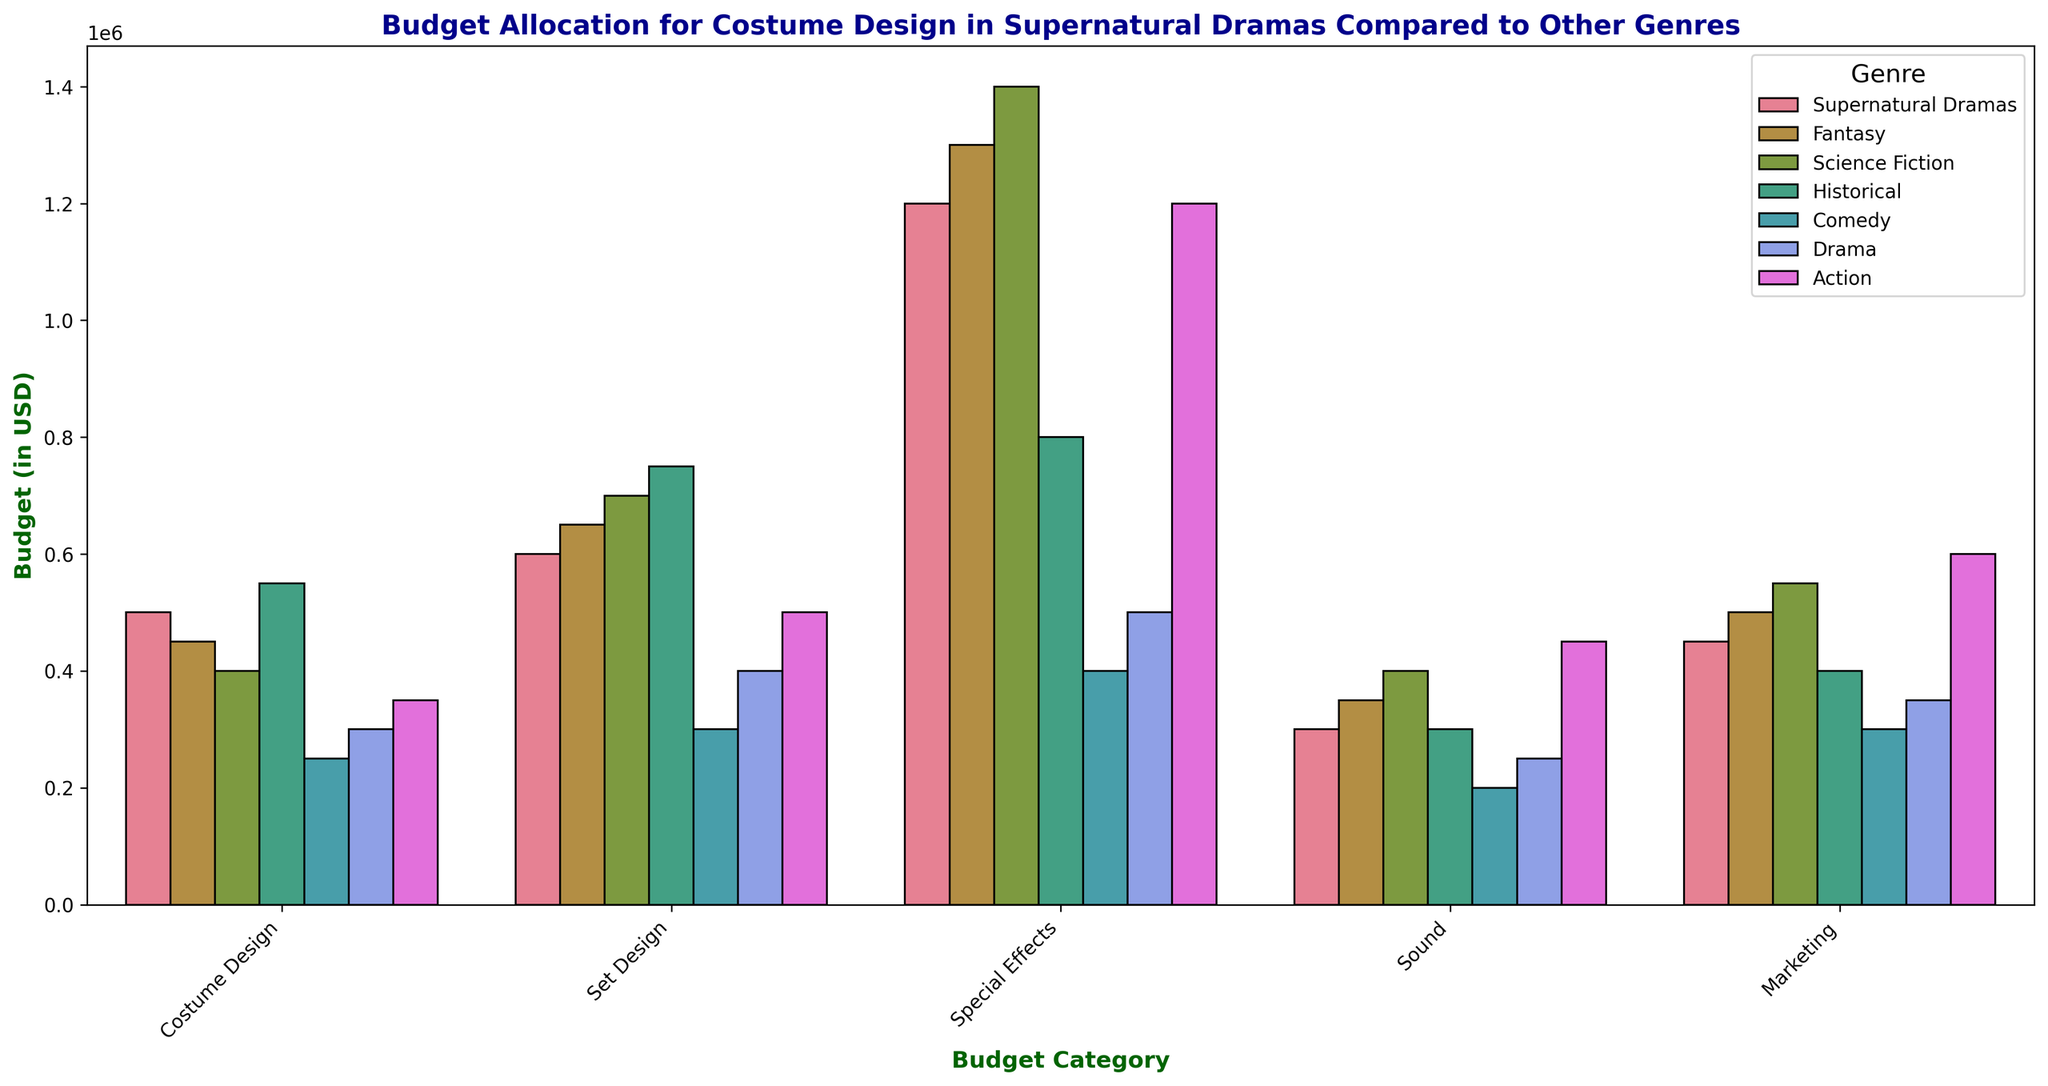How much more budget is allocated to Special Effects compared to Costume Design in Supernatural Dramas? To answer this, first, look at the bars for Supernatural Dramas under Special Effects and Costume Design. The Special Effects bar reaches up to 1,200,000 USD, and the Costume Design bar reaches up to 500,000 USD. Subtract the Costume Design budget from the Special Effects budget (1,200,000 - 500,000).
Answer: 700,000 USD Which genre has the highest budget for Sound? Identify the highest bar in the Sound budget category. The bar for Science Fiction in the Sound category is the tallest, reaching up to 400,000 USD.
Answer: Science Fiction In terms of percentage, how much of the Fantasy genre's total budget contributes to Marketing? First, sum the budget for Fantasy: 450,000 (Costume Design) + 650,000 (Set Design) + 1,300,000 (Special Effects) + 350,000 (Sound) + 500,000 (Marketing) = 3,250,000. Then, calculate the percentage of Marketing: (500,000 / 3,250,000) * 100.
Answer: 15.38% Is the budget for Costume Design in Historical genre greater than in Fantasy genre? Compare the heights of the bars for Costume Design in Historical and Fantasy categories. The Historical genre's Costume Design budget is 550,000 USD, while Fantasy is 450,000 USD. The Historical genre's bar is taller.
Answer: Yes Rank the genres by their Set Design budget from highest to lowest. Look at the heights of the bars in the Set Design category. Historical (750,000), Science Fiction (700,000), Fantasy (650,000), Action (500,000), Drama (400,000), Comedy (300,000).
Answer: Historical, Science Fiction, Fantasy, Action, Drama, Comedy What is the average budget allocated to Marketing across all genres? Sum all Marketing budgets: 450,000 (Supernatural Dramas) + 500,000 (Fantasy) + 550,000 (Science Fiction) + 400,000 (Historical) + 300,000 (Comedy) + 350,000 (Drama) + 600,000 (Action). Then divide by the number of genres (7). (450,000 + 500,000 + 550,000 + 400,000 + 300,000 + 350,000 + 600,000) / 7.
Answer: 450,000 USD How does the budget for Special Effects in Historical genre compare to the budget for Special Effects in Supernatural Dramas? Compare the heights of the Special Effects bars for Historical and Supernatural Dramas. The Historical genre's Special Effects budget is 800,000 USD, while Supernatural Dramas is 1,200,000 USD. The bar for Supernatural Dramas is taller.
Answer: The Supernatural Dramas budget is larger Which genre has the smallest budget for Costume Design? Identify the shortest bar for the Costume Design category. The Comedy genre has the smallest budget for Costume Design at 250,000 USD.
Answer: Comedy What is the total budget for Set Design in Action and Drama genres combined? Sum the Set Design budgets for both genres. Action has 500,000 USD, and Drama has 400,000 USD. Add the two amounts together (500,000 + 400,000).
Answer: 900,000 USD 